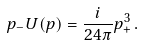<formula> <loc_0><loc_0><loc_500><loc_500>p _ { - } U ( p ) = \frac { i } { 2 4 \pi } p _ { + } ^ { 3 } \, .</formula> 